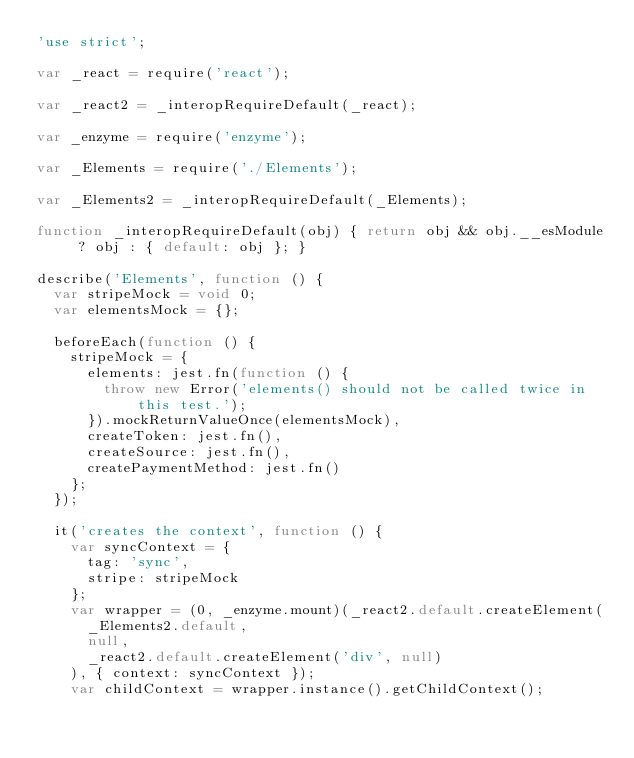Convert code to text. <code><loc_0><loc_0><loc_500><loc_500><_JavaScript_>'use strict';

var _react = require('react');

var _react2 = _interopRequireDefault(_react);

var _enzyme = require('enzyme');

var _Elements = require('./Elements');

var _Elements2 = _interopRequireDefault(_Elements);

function _interopRequireDefault(obj) { return obj && obj.__esModule ? obj : { default: obj }; }

describe('Elements', function () {
  var stripeMock = void 0;
  var elementsMock = {};

  beforeEach(function () {
    stripeMock = {
      elements: jest.fn(function () {
        throw new Error('elements() should not be called twice in this test.');
      }).mockReturnValueOnce(elementsMock),
      createToken: jest.fn(),
      createSource: jest.fn(),
      createPaymentMethod: jest.fn()
    };
  });

  it('creates the context', function () {
    var syncContext = {
      tag: 'sync',
      stripe: stripeMock
    };
    var wrapper = (0, _enzyme.mount)(_react2.default.createElement(
      _Elements2.default,
      null,
      _react2.default.createElement('div', null)
    ), { context: syncContext });
    var childContext = wrapper.instance().getChildContext();</code> 